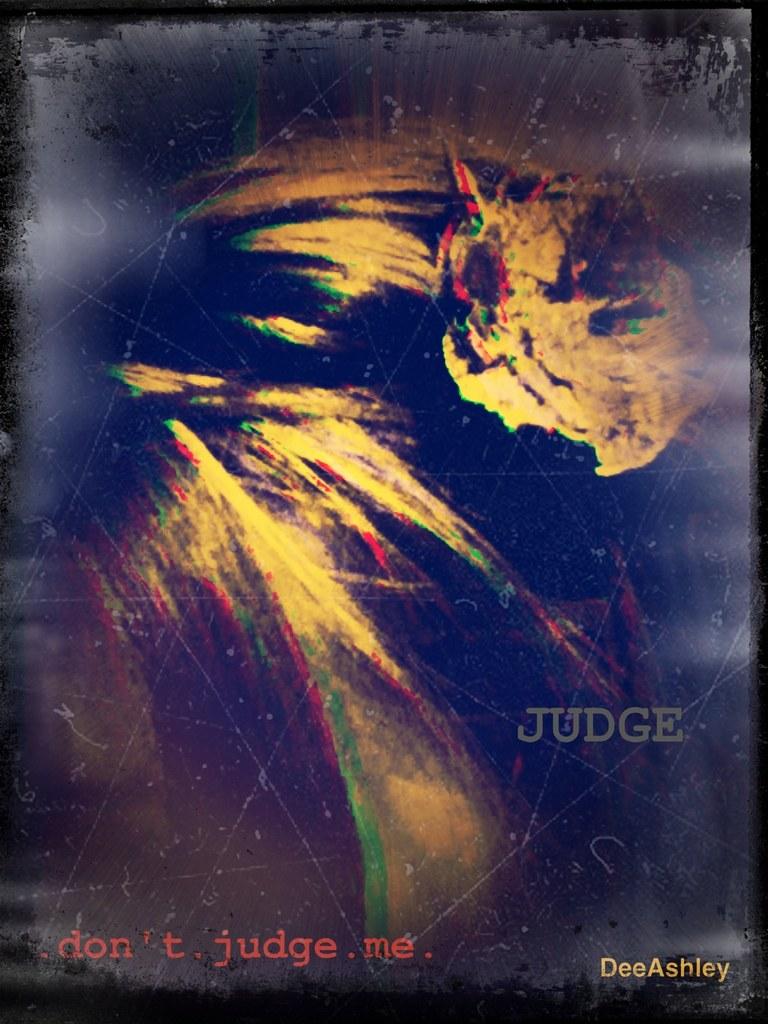Don't judge who?
Make the answer very short. Me. Don't do what to me?
Offer a very short reply. Judge. 